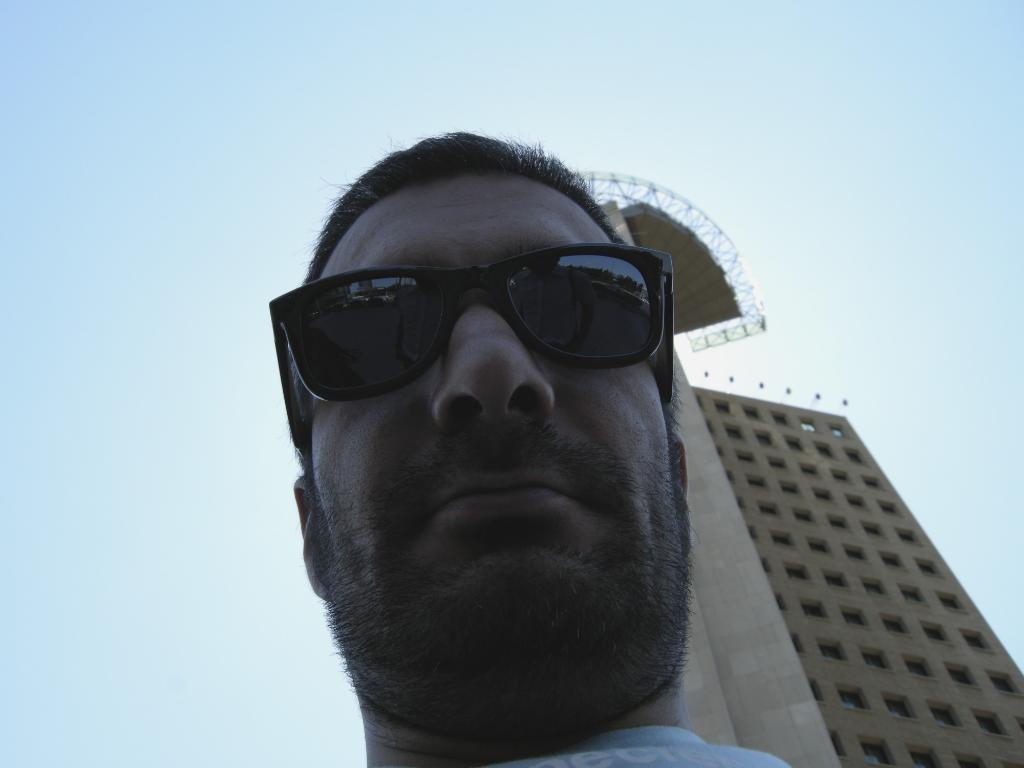What structure is present in the image? There is a building in the image. Who or what can be seen near the building? There is a man standing in the image. What is visible at the top of the image? The sky is visible at the top of the image. What type of road is visible in the image? There is no road visible in the image; it only features a building and a man. 